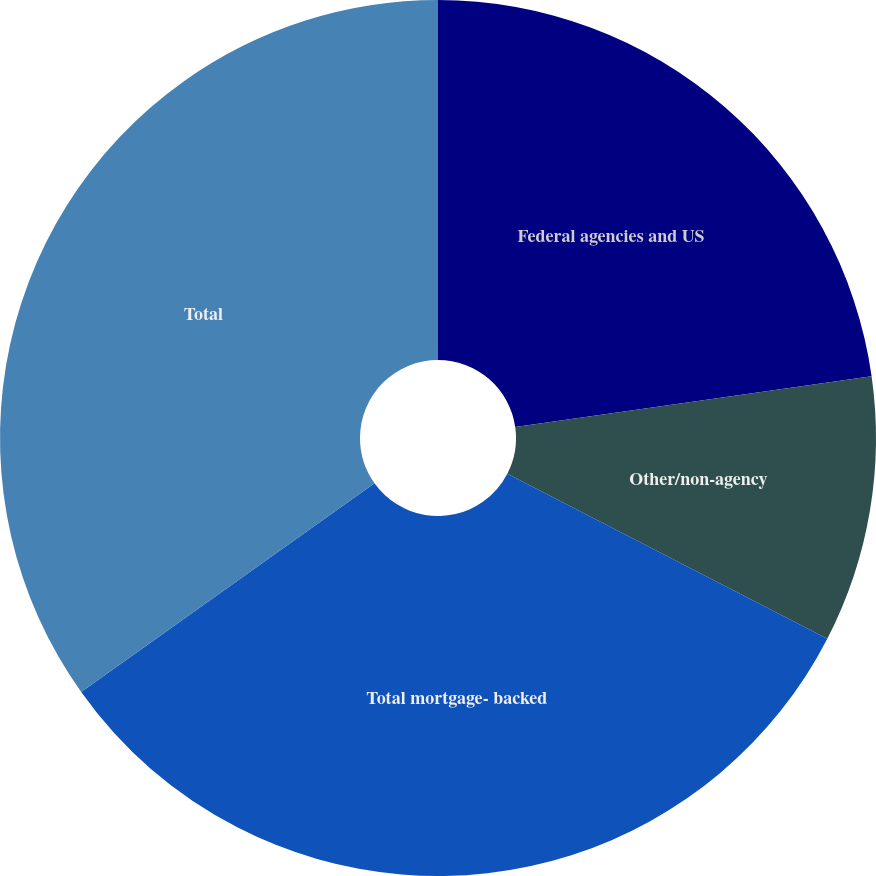Convert chart. <chart><loc_0><loc_0><loc_500><loc_500><pie_chart><fcel>Federal agencies and US<fcel>Other/non-agency<fcel>Total mortgage- backed<fcel>Total<nl><fcel>22.75%<fcel>9.83%<fcel>32.58%<fcel>34.85%<nl></chart> 